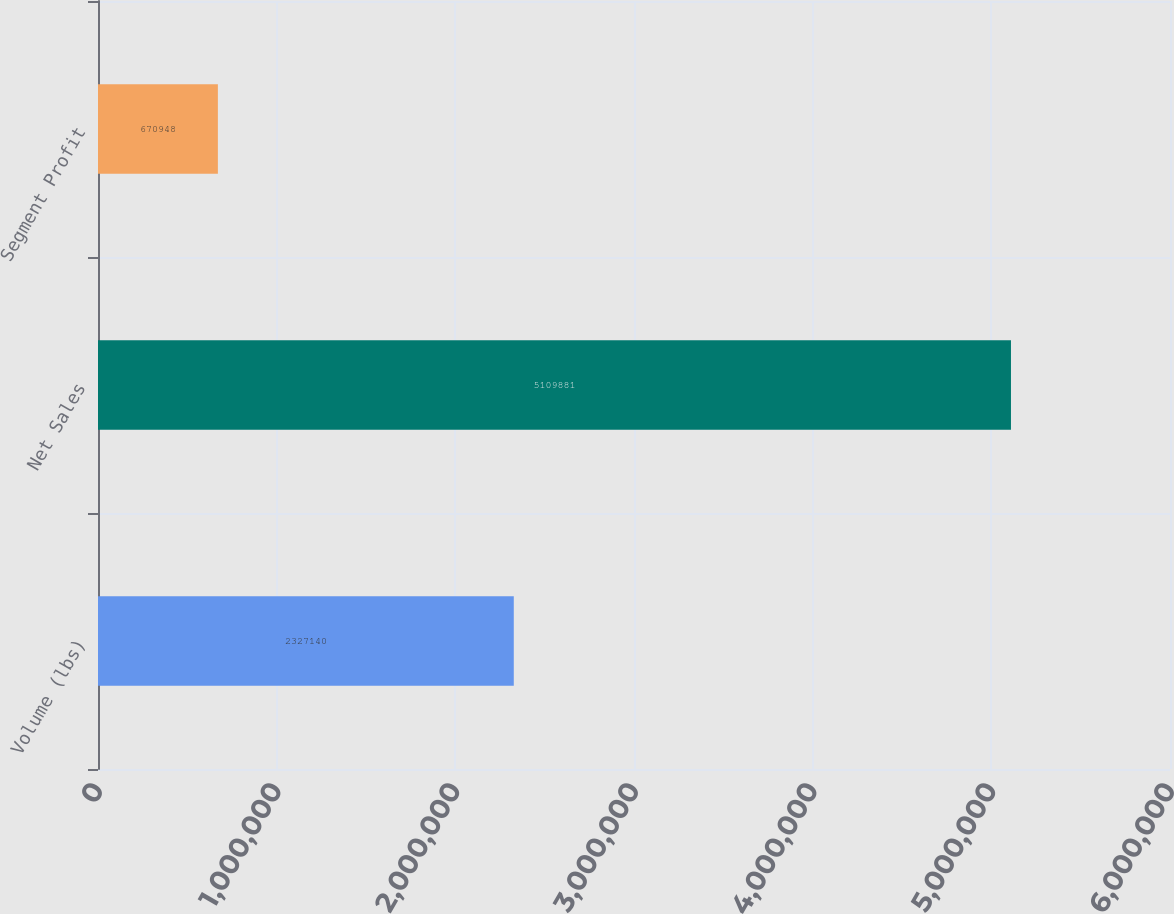Convert chart to OTSL. <chart><loc_0><loc_0><loc_500><loc_500><bar_chart><fcel>Volume (lbs)<fcel>Net Sales<fcel>Segment Profit<nl><fcel>2.32714e+06<fcel>5.10988e+06<fcel>670948<nl></chart> 